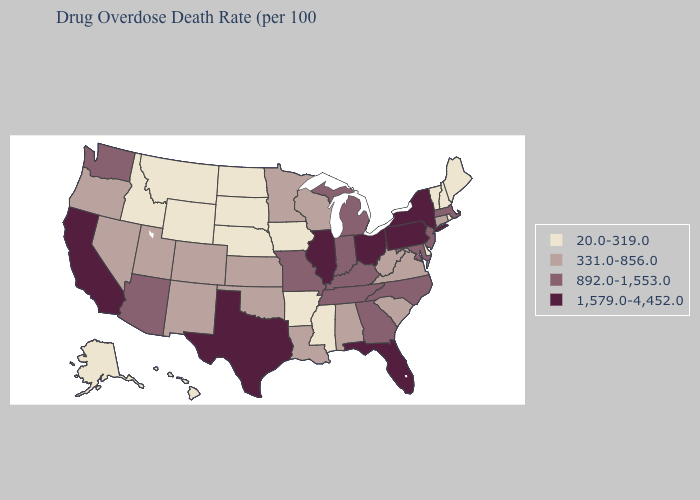What is the value of Mississippi?
Concise answer only. 20.0-319.0. Which states have the lowest value in the USA?
Short answer required. Alaska, Arkansas, Delaware, Hawaii, Idaho, Iowa, Maine, Mississippi, Montana, Nebraska, New Hampshire, North Dakota, Rhode Island, South Dakota, Vermont, Wyoming. Which states have the lowest value in the USA?
Give a very brief answer. Alaska, Arkansas, Delaware, Hawaii, Idaho, Iowa, Maine, Mississippi, Montana, Nebraska, New Hampshire, North Dakota, Rhode Island, South Dakota, Vermont, Wyoming. Does New York have a lower value than New Hampshire?
Give a very brief answer. No. Does Iowa have the same value as Illinois?
Give a very brief answer. No. Which states have the lowest value in the West?
Quick response, please. Alaska, Hawaii, Idaho, Montana, Wyoming. What is the value of Louisiana?
Keep it brief. 331.0-856.0. What is the value of Minnesota?
Answer briefly. 331.0-856.0. Does the map have missing data?
Be succinct. No. What is the value of Kansas?
Short answer required. 331.0-856.0. Among the states that border California , which have the lowest value?
Concise answer only. Nevada, Oregon. Among the states that border Wyoming , which have the highest value?
Answer briefly. Colorado, Utah. What is the value of Oklahoma?
Keep it brief. 331.0-856.0. Which states have the highest value in the USA?
Keep it brief. California, Florida, Illinois, New York, Ohio, Pennsylvania, Texas. What is the highest value in the Northeast ?
Be succinct. 1,579.0-4,452.0. 